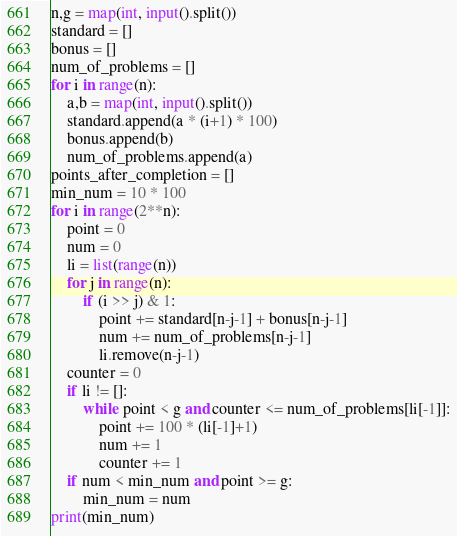<code> <loc_0><loc_0><loc_500><loc_500><_Python_>n,g = map(int, input().split())
standard = []
bonus = []
num_of_problems = []
for i in range(n):
    a,b = map(int, input().split())
    standard.append(a * (i+1) * 100)
    bonus.append(b)
    num_of_problems.append(a)
points_after_completion = []
min_num = 10 * 100
for i in range(2**n):
    point = 0
    num = 0
    li = list(range(n))
    for j in range(n):
        if (i >> j) & 1:
            point += standard[n-j-1] + bonus[n-j-1]
            num += num_of_problems[n-j-1]
            li.remove(n-j-1)
    counter = 0
    if li != []:
        while point < g and counter <= num_of_problems[li[-1]]:
            point += 100 * (li[-1]+1)
            num += 1
            counter += 1
    if num < min_num and point >= g:
        min_num = num
print(min_num)
</code> 